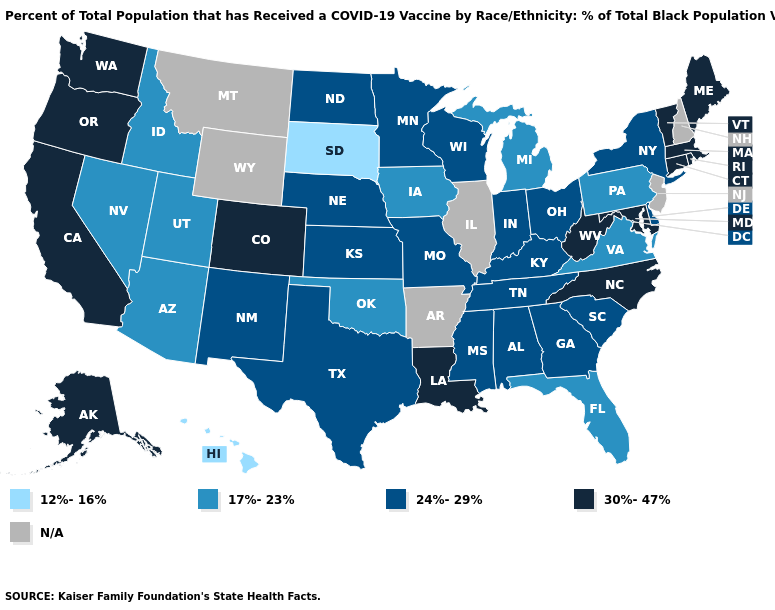Name the states that have a value in the range 24%-29%?
Give a very brief answer. Alabama, Delaware, Georgia, Indiana, Kansas, Kentucky, Minnesota, Mississippi, Missouri, Nebraska, New Mexico, New York, North Dakota, Ohio, South Carolina, Tennessee, Texas, Wisconsin. Among the states that border South Dakota , which have the lowest value?
Keep it brief. Iowa. What is the value of New York?
Keep it brief. 24%-29%. What is the highest value in states that border Montana?
Concise answer only. 24%-29%. Which states have the lowest value in the Northeast?
Concise answer only. Pennsylvania. How many symbols are there in the legend?
Write a very short answer. 5. Which states have the lowest value in the USA?
Write a very short answer. Hawaii, South Dakota. What is the value of Wisconsin?
Short answer required. 24%-29%. Does Hawaii have the lowest value in the West?
Give a very brief answer. Yes. What is the highest value in the USA?
Answer briefly. 30%-47%. Name the states that have a value in the range 30%-47%?
Short answer required. Alaska, California, Colorado, Connecticut, Louisiana, Maine, Maryland, Massachusetts, North Carolina, Oregon, Rhode Island, Vermont, Washington, West Virginia. Does the map have missing data?
Quick response, please. Yes. Name the states that have a value in the range 12%-16%?
Be succinct. Hawaii, South Dakota. 